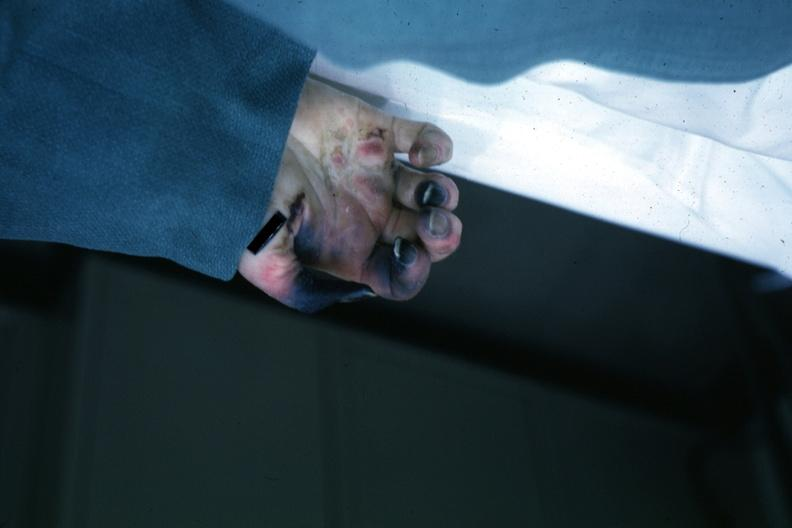what is present?
Answer the question using a single word or phrase. Hand 